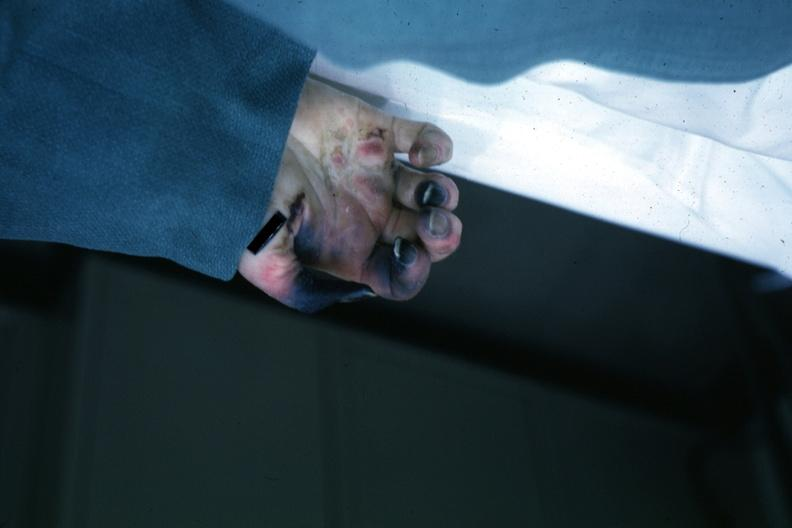what is present?
Answer the question using a single word or phrase. Hand 